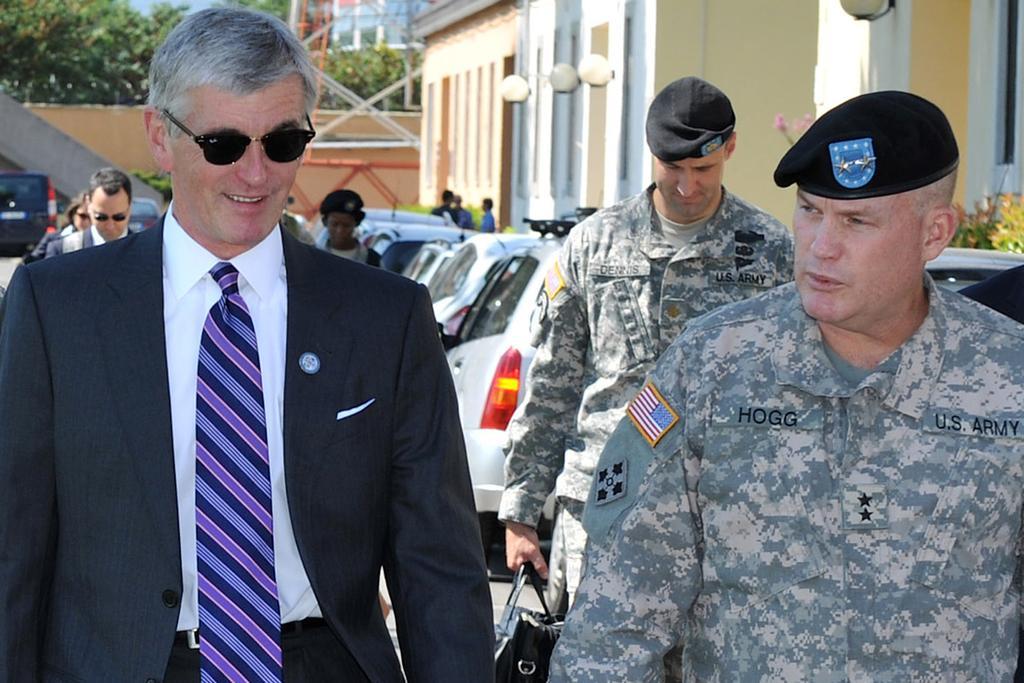Describe this image in one or two sentences. This picture describes about group of people, few people wore spectacles and few people wore caps, in the background we can see few vehicles, buildings, lights, trees and a tower, on the right side of the image we can see a man, he is holding a bag. 